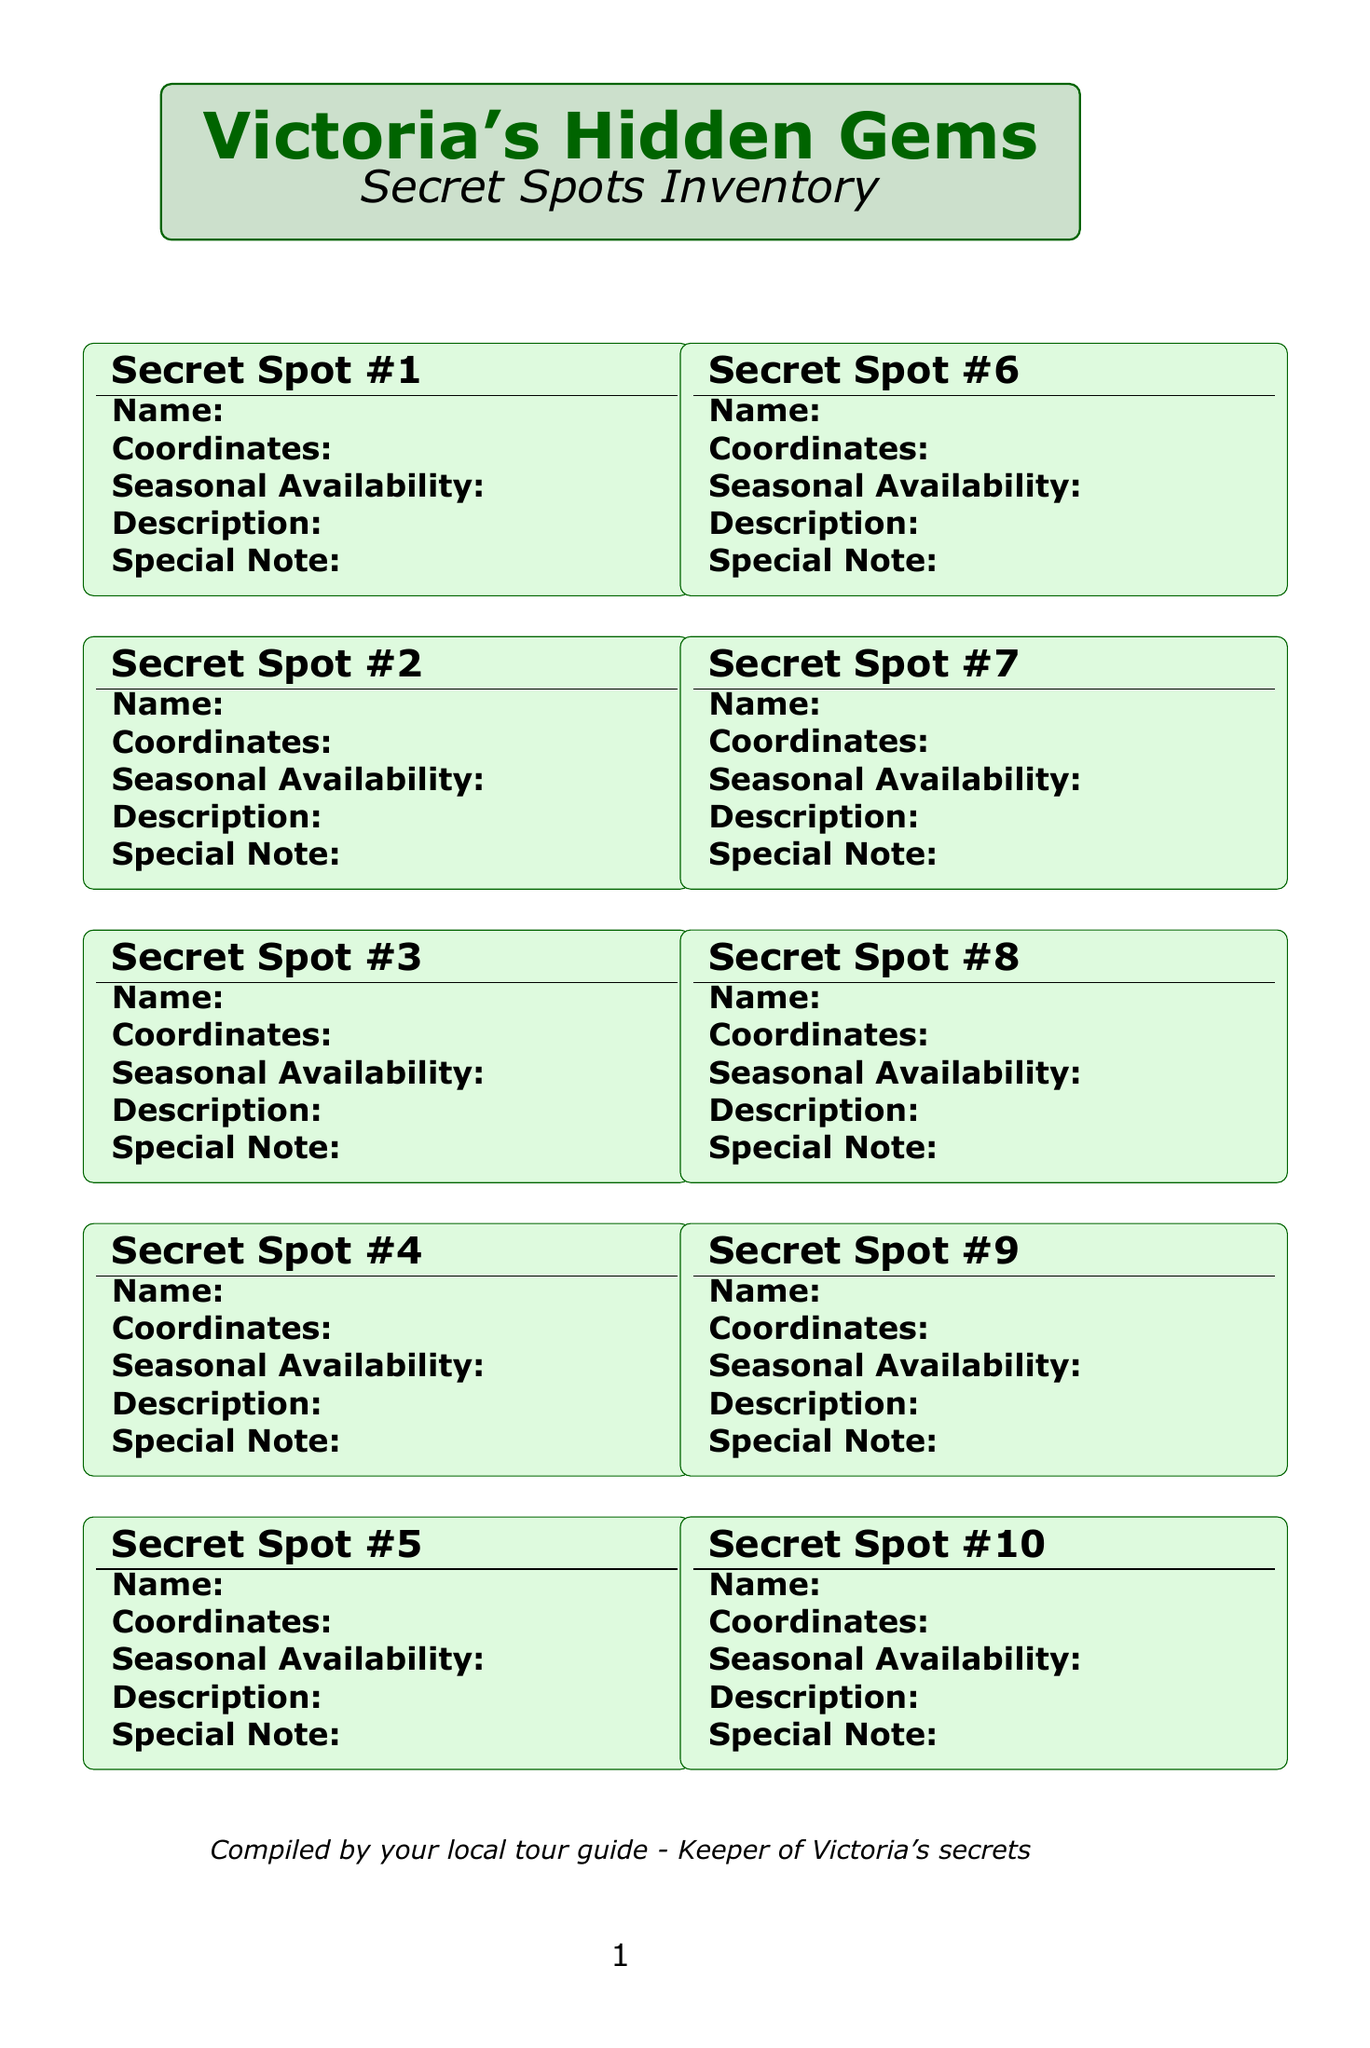What is the name of the hidden beach? The hidden beach is referred to as "Hidden Beach at Witty's Lagoon" in the document.
Answer: Hidden Beach at Witty's Lagoon What is the seasonal availability for Sooke Potholes Secret Cliff Jump? The document specifies that this spot is available from late spring to early fall, which is May to September.
Answer: Late spring to early fall (May-September) What coordinates correspond to Tod Inlet Hidden Ruins? The coordinates provided in the document for this location are 48.5667° N, 123.4667° W.
Answer: 48.5667° N, 123.4667° W Which secret spot has the best visibility during winter? The document mentions that the Durrance Lake Float Plane Wreck has the best visibility in winter when water levels are lower.
Answer: Durrance Lake Float Plane Wreck What type of experience does Gonzales Observatory offer? The document details that this location is perfect for stargazing away from city lights, making it a unique experience.
Answer: Stargazing What feature does Lotus Land Lavender Farm offer during lavender bloom season? The document highlights that visitors can participate in U-pick lavender and essential oil distillation demonstrations during this time.
Answer: U-pick lavender and essential oil distillation demonstrations What is the historical significance of Tod Inlet Hidden Ruins? The document notes that it is an early 20th-century industrial heritage site, providing historical context.
Answer: Early 20th-century industrial heritage site What is the difficulty level of the Mount Work Summit Trail? The document categorizes this trail as moderate to difficult, indicating its challenge level for hikers.
Answer: Moderate to difficult During which season is the Elk Lake Bird Sanctuary Boardwalk best for bird watching? The document specifies that the best times for bird watching at this location are during spring and fall migrations.
Answer: Spring and fall migrations 